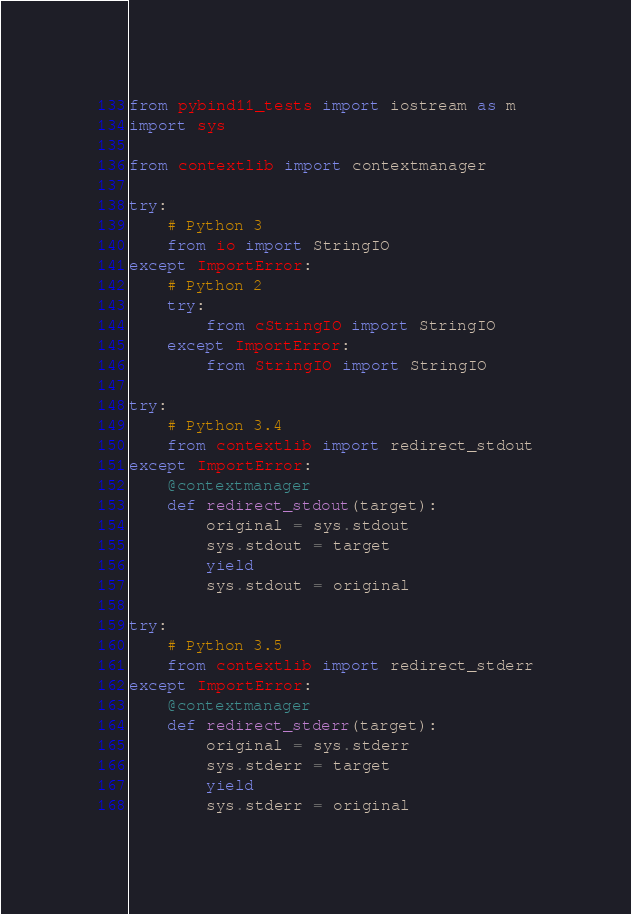Convert code to text. <code><loc_0><loc_0><loc_500><loc_500><_Python_>from pybind11_tests import iostream as m
import sys

from contextlib import contextmanager

try:
    # Python 3
    from io import StringIO
except ImportError:
    # Python 2
    try:
        from cStringIO import StringIO
    except ImportError:
        from StringIO import StringIO

try:
    # Python 3.4
    from contextlib import redirect_stdout
except ImportError:
    @contextmanager
    def redirect_stdout(target):
        original = sys.stdout
        sys.stdout = target
        yield
        sys.stdout = original

try:
    # Python 3.5
    from contextlib import redirect_stderr
except ImportError:
    @contextmanager
    def redirect_stderr(target):
        original = sys.stderr
        sys.stderr = target
        yield
        sys.stderr = original

</code> 